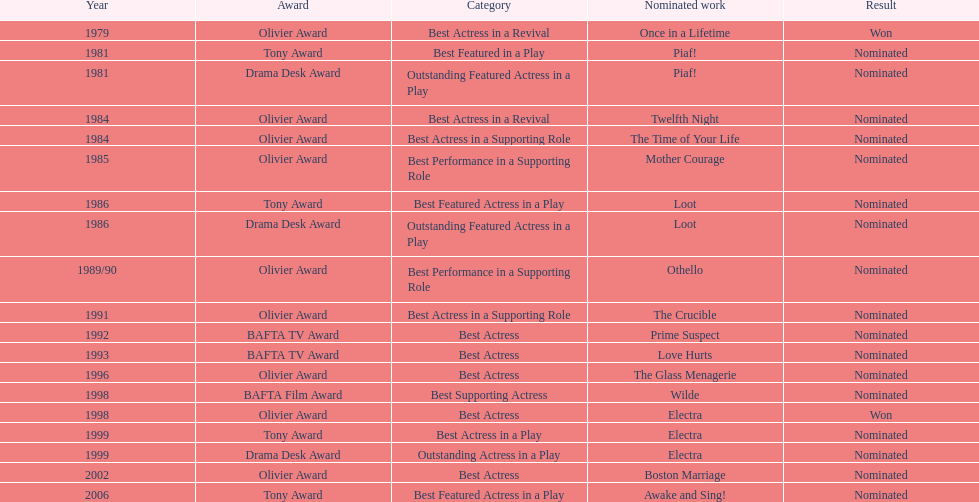What year was prime suspects nominated for the bafta tv award? 1992. Write the full table. {'header': ['Year', 'Award', 'Category', 'Nominated work', 'Result'], 'rows': [['1979', 'Olivier Award', 'Best Actress in a Revival', 'Once in a Lifetime', 'Won'], ['1981', 'Tony Award', 'Best Featured in a Play', 'Piaf!', 'Nominated'], ['1981', 'Drama Desk Award', 'Outstanding Featured Actress in a Play', 'Piaf!', 'Nominated'], ['1984', 'Olivier Award', 'Best Actress in a Revival', 'Twelfth Night', 'Nominated'], ['1984', 'Olivier Award', 'Best Actress in a Supporting Role', 'The Time of Your Life', 'Nominated'], ['1985', 'Olivier Award', 'Best Performance in a Supporting Role', 'Mother Courage', 'Nominated'], ['1986', 'Tony Award', 'Best Featured Actress in a Play', 'Loot', 'Nominated'], ['1986', 'Drama Desk Award', 'Outstanding Featured Actress in a Play', 'Loot', 'Nominated'], ['1989/90', 'Olivier Award', 'Best Performance in a Supporting Role', 'Othello', 'Nominated'], ['1991', 'Olivier Award', 'Best Actress in a Supporting Role', 'The Crucible', 'Nominated'], ['1992', 'BAFTA TV Award', 'Best Actress', 'Prime Suspect', 'Nominated'], ['1993', 'BAFTA TV Award', 'Best Actress', 'Love Hurts', 'Nominated'], ['1996', 'Olivier Award', 'Best Actress', 'The Glass Menagerie', 'Nominated'], ['1998', 'BAFTA Film Award', 'Best Supporting Actress', 'Wilde', 'Nominated'], ['1998', 'Olivier Award', 'Best Actress', 'Electra', 'Won'], ['1999', 'Tony Award', 'Best Actress in a Play', 'Electra', 'Nominated'], ['1999', 'Drama Desk Award', 'Outstanding Actress in a Play', 'Electra', 'Nominated'], ['2002', 'Olivier Award', 'Best Actress', 'Boston Marriage', 'Nominated'], ['2006', 'Tony Award', 'Best Featured Actress in a Play', 'Awake and Sing!', 'Nominated']]} 